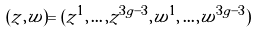<formula> <loc_0><loc_0><loc_500><loc_500>( z , w ) = ( z ^ { 1 } , \dots , z ^ { 3 g - 3 } , w ^ { 1 } , \dots , w ^ { 3 g - 3 } )</formula> 